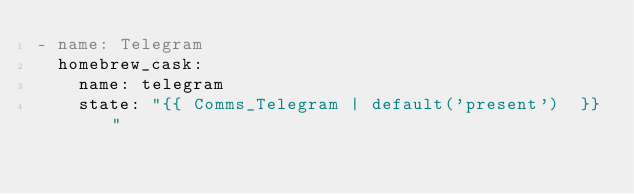Convert code to text. <code><loc_0><loc_0><loc_500><loc_500><_YAML_>- name: Telegram
  homebrew_cask:
    name: telegram
    state: "{{ Comms_Telegram | default('present')  }}"
    
</code> 